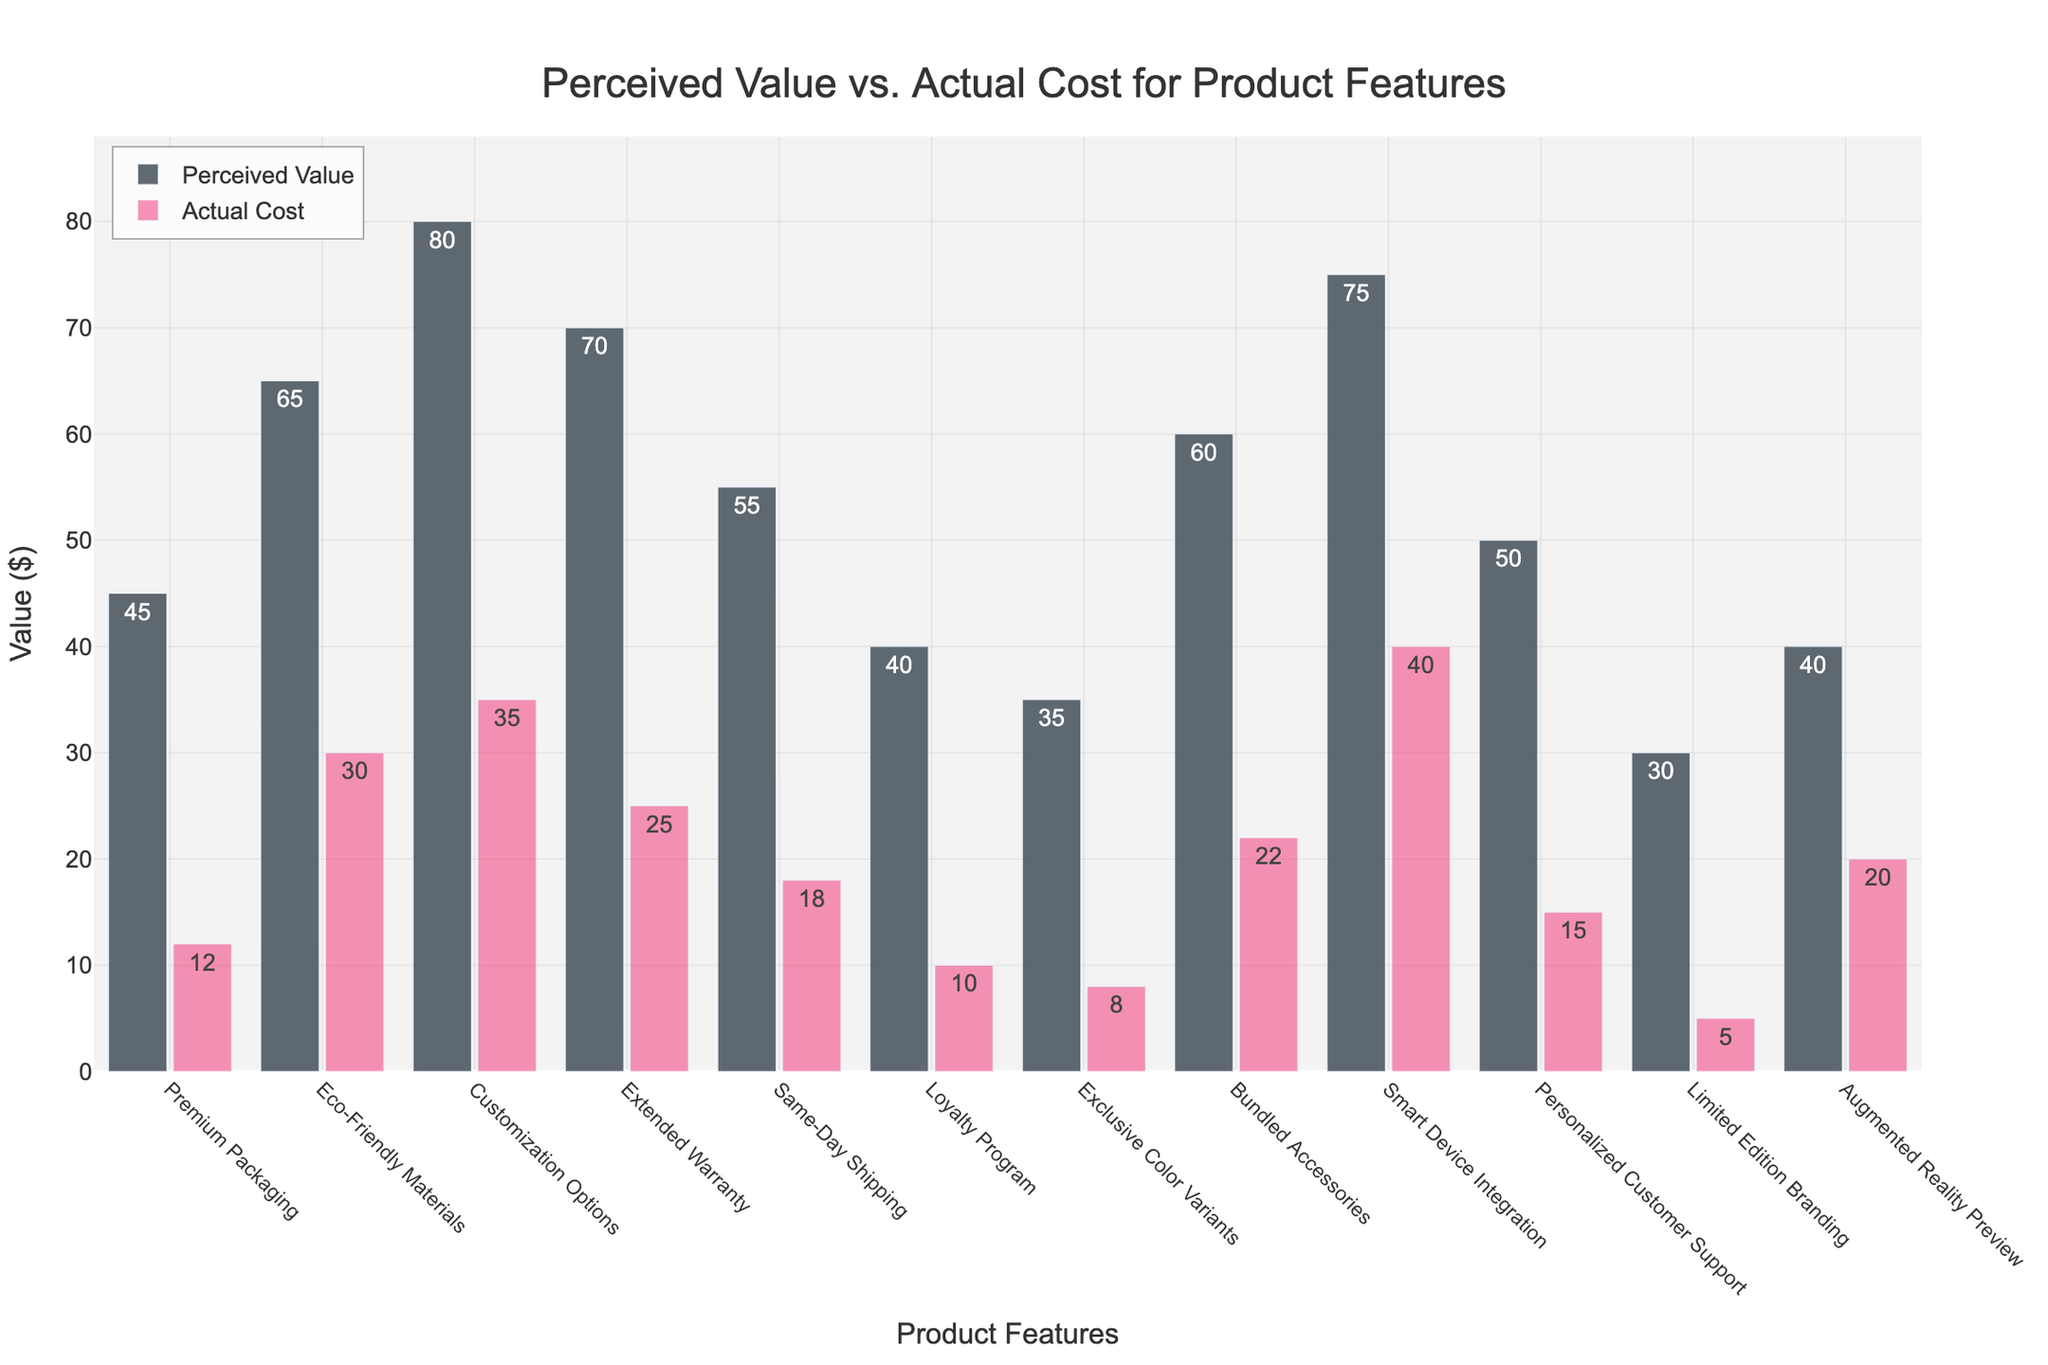What's the feature with the highest perceived value? To determine this, look at the highest bar in the 'Perceived Value' series. Observe the y-axis values and find the feature with the tallest bar.
Answer: Customization Options Which feature has the largest difference between perceived value and actual cost? Compute the differences between the perceived value and actual cost for each feature, then identify the largest difference. For example, (Customization Options: 80 - 35 = 45), (Eco-Friendly Materials: 65 - 30 = 35), etc. Choose the feature with the highest value.
Answer: Customization Options What is the sum of the actual costs for Premium Packaging and Loyalty Program? Sum the actual costs of Premium Packaging and Loyalty Program. For Premium Packaging the value is 12, and for Loyalty Program it's 10. Sum these values: 12 + 10 = 22.
Answer: 22 How much more is the perceived value of Same-Day Shipping compared to the actual cost of Extended Warranty? Find the perceived value of Same-Day Shipping (55) and subtract the actual cost of Extended Warranty (25). Calculate 55 - 25.
Answer: 30 What is the average actual cost for the features with the top three highest perceived values? Identify the top three highest perceived values (Customization Options, Smart Device Integration, Extended Warranty). Their actual costs are 35, 40, and 25 respectively. Calculate the average: (35 + 40 + 25) / 3.
Answer: 33.33 Which feature’s actual cost is closest to its perceived value? Calculate the absolute difference between perceived value and actual cost for each feature. Determine which feature has the smallest difference.
Answer: Loyalty Program What is the perceived value to actual cost ratio for Smart Device Integration? Divide the perceived value by the actual cost for Smart Device Integration: 75 / 40.
Answer: 1.875 Which feature has the lowest actual cost? Find the shortest bar in the 'Actual Cost' series, referring to the y-axis values.
Answer: Limited Edition Branding 